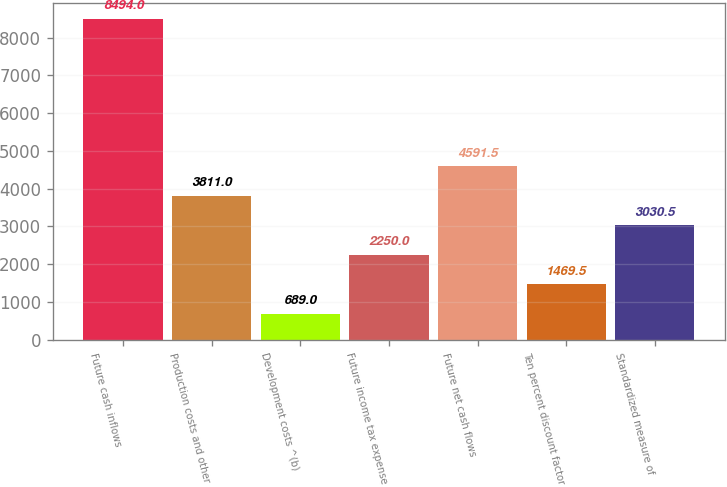Convert chart to OTSL. <chart><loc_0><loc_0><loc_500><loc_500><bar_chart><fcel>Future cash inflows<fcel>Production costs and other<fcel>Development costs ^(b)<fcel>Future income tax expense<fcel>Future net cash flows<fcel>Ten percent discount factor<fcel>Standardized measure of<nl><fcel>8494<fcel>3811<fcel>689<fcel>2250<fcel>4591.5<fcel>1469.5<fcel>3030.5<nl></chart> 